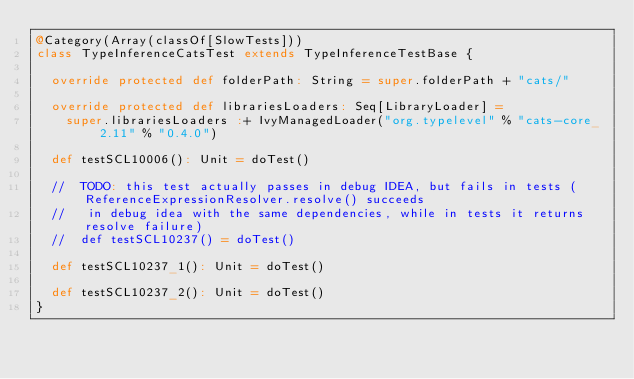<code> <loc_0><loc_0><loc_500><loc_500><_Scala_>@Category(Array(classOf[SlowTests]))
class TypeInferenceCatsTest extends TypeInferenceTestBase {

  override protected def folderPath: String = super.folderPath + "cats/"

  override protected def librariesLoaders: Seq[LibraryLoader] =
    super.librariesLoaders :+ IvyManagedLoader("org.typelevel" % "cats-core_2.11" % "0.4.0")

  def testSCL10006(): Unit = doTest()

  //  TODO: this test actually passes in debug IDEA, but fails in tests (ReferenceExpressionResolver.resolve() succeeds
  //   in debug idea with the same dependencies, while in tests it returns resolve failure)
  //  def testSCL10237() = doTest()

  def testSCL10237_1(): Unit = doTest()

  def testSCL10237_2(): Unit = doTest()
}
</code> 